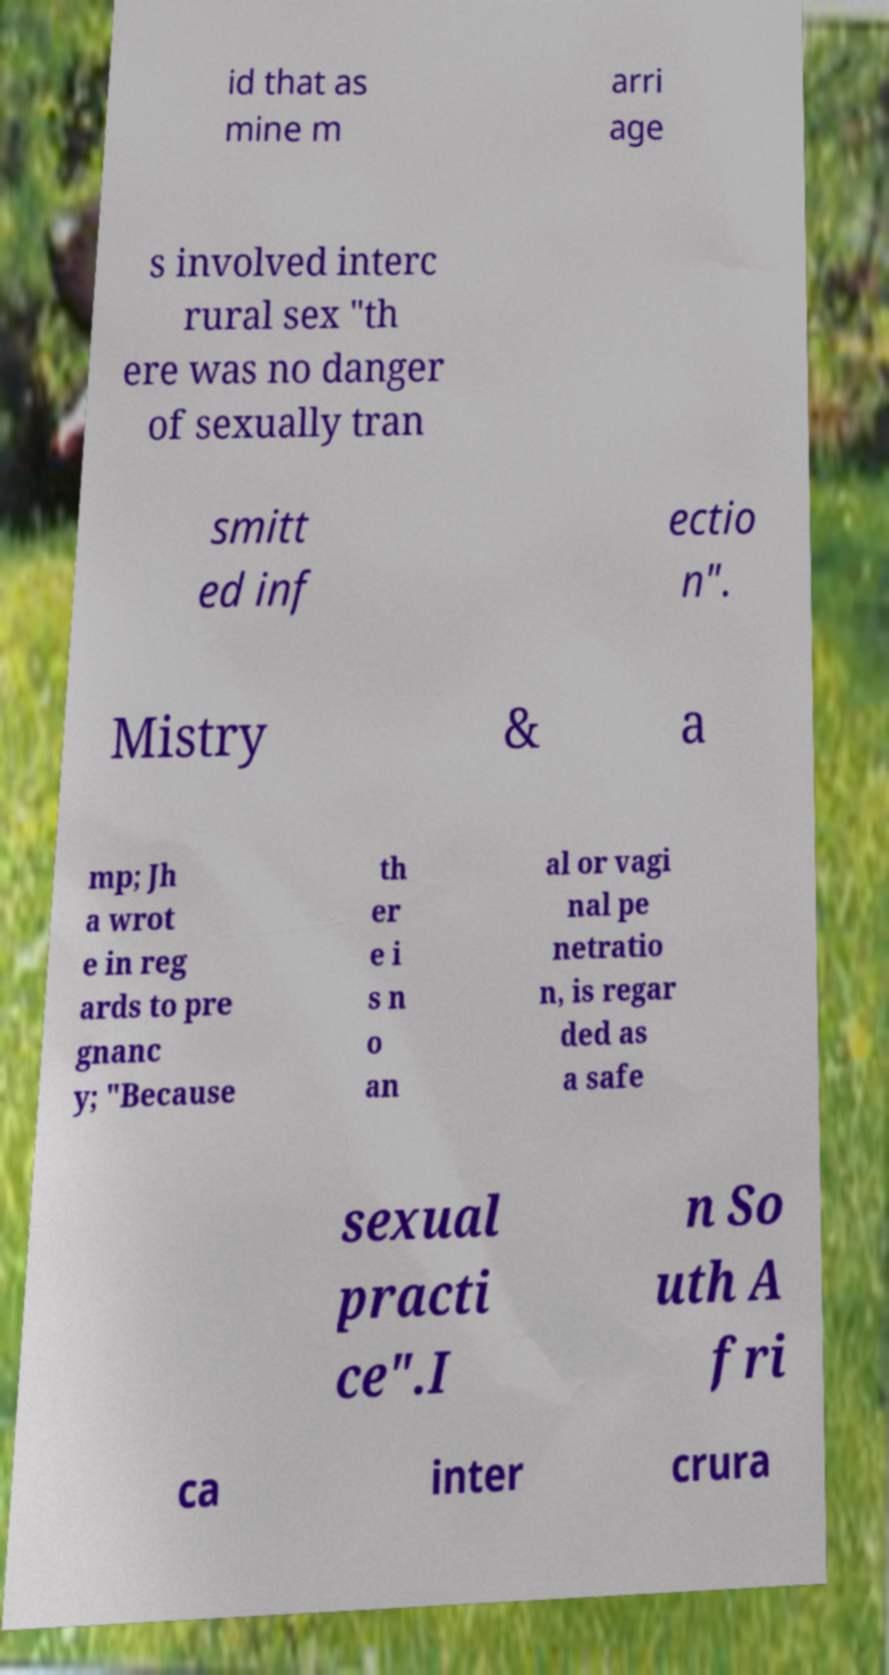Please read and relay the text visible in this image. What does it say? id that as mine m arri age s involved interc rural sex "th ere was no danger of sexually tran smitt ed inf ectio n". Mistry & a mp; Jh a wrot e in reg ards to pre gnanc y; "Because th er e i s n o an al or vagi nal pe netratio n, is regar ded as a safe sexual practi ce".I n So uth A fri ca inter crura 